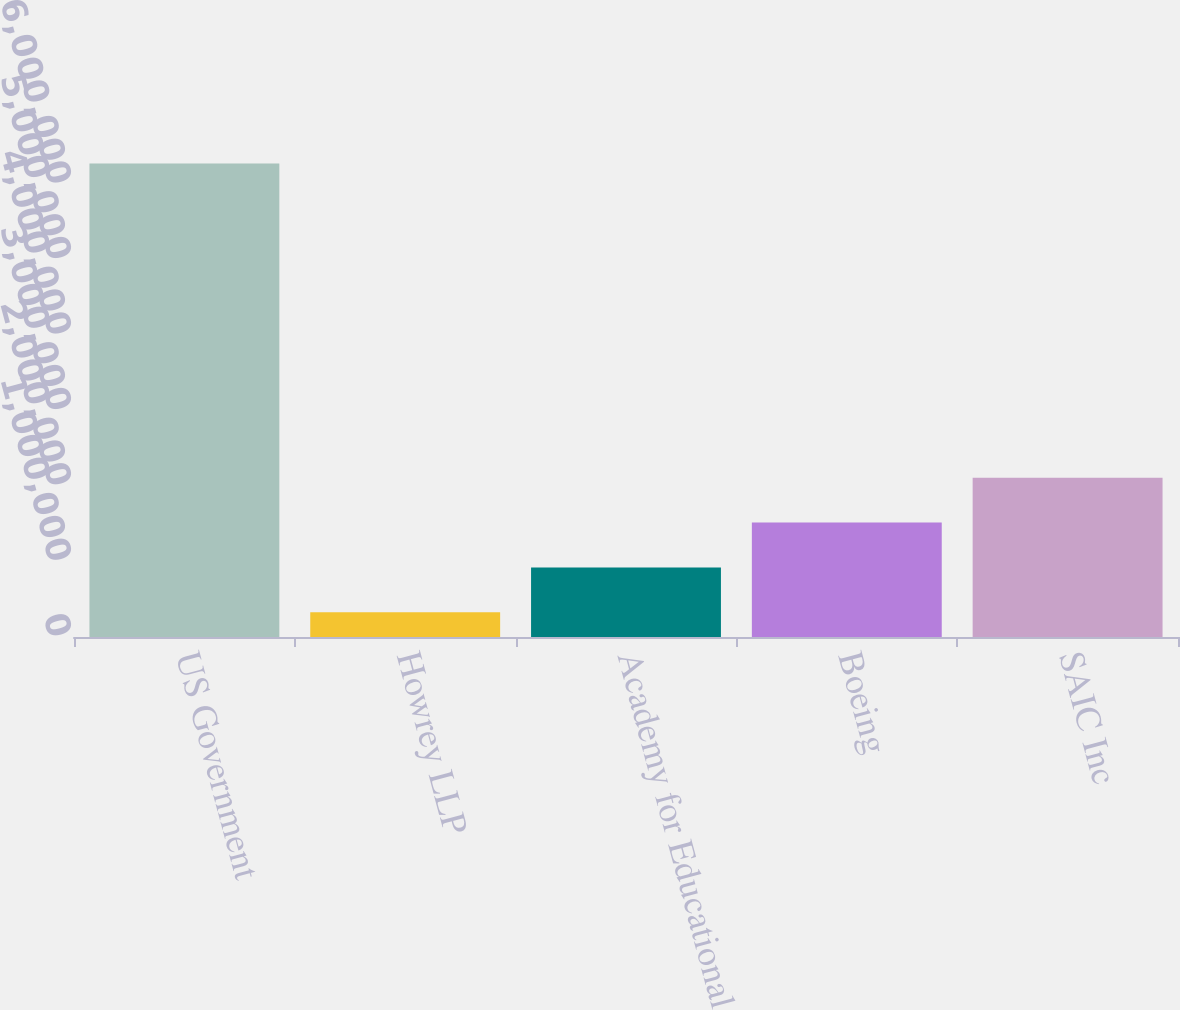Convert chart. <chart><loc_0><loc_0><loc_500><loc_500><bar_chart><fcel>US Government<fcel>Howrey LLP<fcel>Academy for Educational<fcel>Boeing<fcel>SAIC Inc<nl><fcel>6.277e+06<fcel>327000<fcel>922000<fcel>1.517e+06<fcel>2.112e+06<nl></chart> 